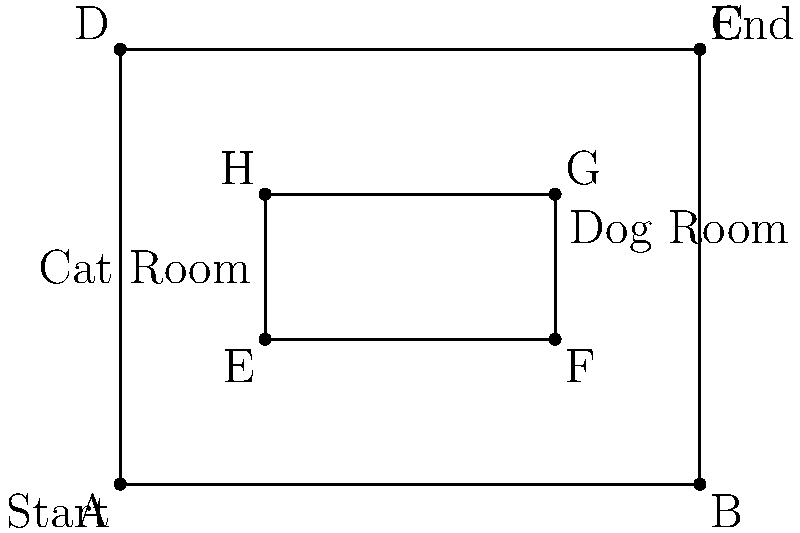Given the shelter layout above, what is the most efficient feeding route that covers all areas, starting from point A and ending at point C, if you need to visit both the cat and dog rooms? Calculate the total distance traveled in units, assuming each grid square is 1 unit. To find the most efficient feeding route, we need to minimize the total distance traveled while visiting all required points. Let's break this down step-by-step:

1. We start at point A and need to end at point C.
2. We must visit both the cat room (represented by the rectangle EFGH) and the dog room.
3. The most efficient path will avoid backtracking and use the shortest routes between points.

The optimal route is:
A → E → H → G → F → B → C

Let's calculate the distance:
1. A to E: $\sqrt{1^2 + 1^2} = \sqrt{2}$ units
2. E to H: 1 unit
3. H to G: 2 units
4. G to F: 1 unit
5. F to B: 1 unit
6. B to C: 3 units

Total distance = $\sqrt{2} + 1 + 2 + 1 + 1 + 3 = 7 + \sqrt{2}$ units

This route ensures we visit both rooms and cover all necessary areas with the shortest possible path.
Answer: $7 + \sqrt{2}$ units 